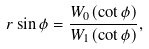<formula> <loc_0><loc_0><loc_500><loc_500>r \sin \phi = \frac { W _ { 0 } ( \cot \phi ) } { W _ { 1 } ( \cot \phi ) } ,</formula> 